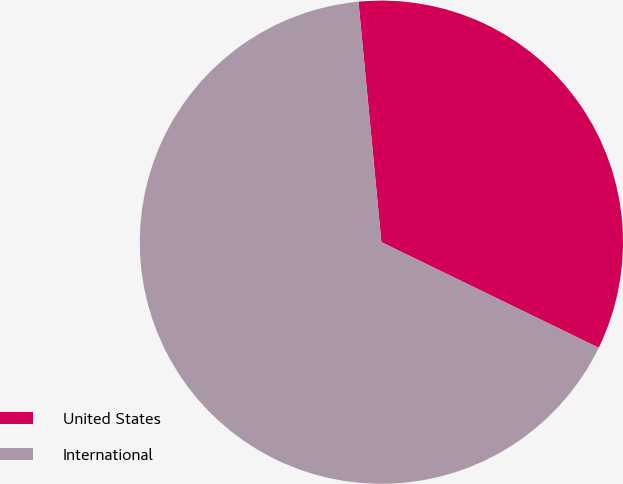Convert chart. <chart><loc_0><loc_0><loc_500><loc_500><pie_chart><fcel>United States<fcel>International<nl><fcel>33.71%<fcel>66.29%<nl></chart> 